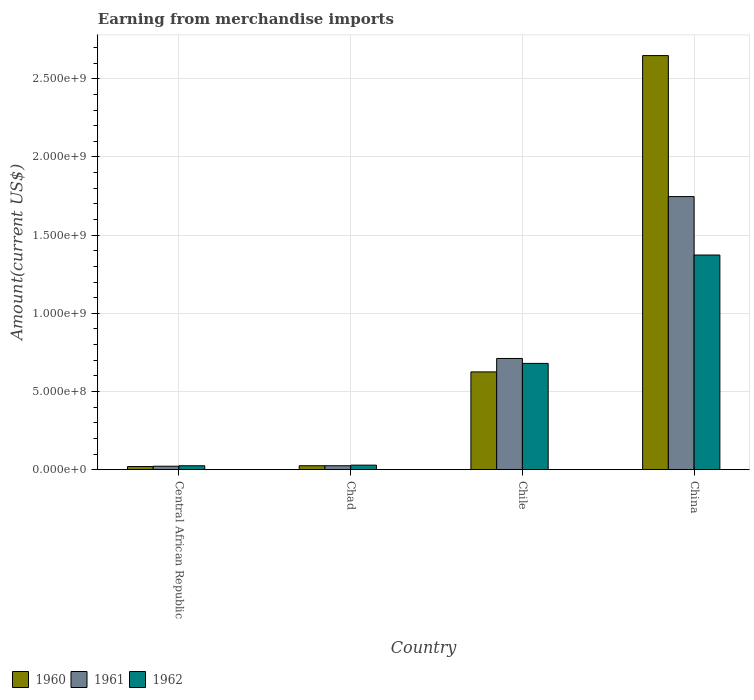How many bars are there on the 2nd tick from the left?
Make the answer very short. 3. How many bars are there on the 4th tick from the right?
Ensure brevity in your answer.  3. What is the label of the 2nd group of bars from the left?
Give a very brief answer. Chad. In how many cases, is the number of bars for a given country not equal to the number of legend labels?
Keep it short and to the point. 0. What is the amount earned from merchandise imports in 1960 in Chile?
Your response must be concise. 6.25e+08. Across all countries, what is the maximum amount earned from merchandise imports in 1961?
Make the answer very short. 1.75e+09. Across all countries, what is the minimum amount earned from merchandise imports in 1962?
Keep it short and to the point. 2.52e+07. In which country was the amount earned from merchandise imports in 1961 minimum?
Your answer should be very brief. Central African Republic. What is the total amount earned from merchandise imports in 1961 in the graph?
Ensure brevity in your answer.  2.51e+09. What is the difference between the amount earned from merchandise imports in 1962 in Chad and that in Chile?
Keep it short and to the point. -6.51e+08. What is the difference between the amount earned from merchandise imports in 1962 in Chad and the amount earned from merchandise imports in 1961 in Chile?
Ensure brevity in your answer.  -6.82e+08. What is the average amount earned from merchandise imports in 1961 per country?
Ensure brevity in your answer.  6.26e+08. What is the difference between the amount earned from merchandise imports of/in 1960 and amount earned from merchandise imports of/in 1961 in Chile?
Offer a very short reply. -8.59e+07. What is the ratio of the amount earned from merchandise imports in 1961 in Chad to that in China?
Offer a terse response. 0.01. Is the difference between the amount earned from merchandise imports in 1960 in Chad and Chile greater than the difference between the amount earned from merchandise imports in 1961 in Chad and Chile?
Your response must be concise. Yes. What is the difference between the highest and the second highest amount earned from merchandise imports in 1961?
Your answer should be very brief. 1.72e+09. What is the difference between the highest and the lowest amount earned from merchandise imports in 1960?
Your answer should be very brief. 2.63e+09. What does the 3rd bar from the right in China represents?
Offer a very short reply. 1960. Is it the case that in every country, the sum of the amount earned from merchandise imports in 1962 and amount earned from merchandise imports in 1960 is greater than the amount earned from merchandise imports in 1961?
Offer a terse response. Yes. Are all the bars in the graph horizontal?
Keep it short and to the point. No. What is the difference between two consecutive major ticks on the Y-axis?
Offer a terse response. 5.00e+08. Are the values on the major ticks of Y-axis written in scientific E-notation?
Offer a terse response. Yes. Does the graph contain grids?
Offer a very short reply. Yes. How are the legend labels stacked?
Make the answer very short. Horizontal. What is the title of the graph?
Your answer should be very brief. Earning from merchandise imports. What is the label or title of the X-axis?
Your response must be concise. Country. What is the label or title of the Y-axis?
Your answer should be very brief. Amount(current US$). What is the Amount(current US$) of 1960 in Central African Republic?
Your answer should be very brief. 2.01e+07. What is the Amount(current US$) in 1961 in Central African Republic?
Make the answer very short. 2.23e+07. What is the Amount(current US$) of 1962 in Central African Republic?
Offer a very short reply. 2.52e+07. What is the Amount(current US$) in 1960 in Chad?
Your answer should be very brief. 2.53e+07. What is the Amount(current US$) of 1961 in Chad?
Your answer should be very brief. 2.53e+07. What is the Amount(current US$) of 1962 in Chad?
Provide a succinct answer. 2.91e+07. What is the Amount(current US$) in 1960 in Chile?
Provide a short and direct response. 6.25e+08. What is the Amount(current US$) in 1961 in Chile?
Keep it short and to the point. 7.11e+08. What is the Amount(current US$) in 1962 in Chile?
Make the answer very short. 6.80e+08. What is the Amount(current US$) in 1960 in China?
Offer a terse response. 2.65e+09. What is the Amount(current US$) in 1961 in China?
Your answer should be very brief. 1.75e+09. What is the Amount(current US$) of 1962 in China?
Your answer should be very brief. 1.37e+09. Across all countries, what is the maximum Amount(current US$) of 1960?
Ensure brevity in your answer.  2.65e+09. Across all countries, what is the maximum Amount(current US$) of 1961?
Provide a succinct answer. 1.75e+09. Across all countries, what is the maximum Amount(current US$) in 1962?
Keep it short and to the point. 1.37e+09. Across all countries, what is the minimum Amount(current US$) of 1960?
Your response must be concise. 2.01e+07. Across all countries, what is the minimum Amount(current US$) of 1961?
Keep it short and to the point. 2.23e+07. Across all countries, what is the minimum Amount(current US$) of 1962?
Your response must be concise. 2.52e+07. What is the total Amount(current US$) in 1960 in the graph?
Provide a short and direct response. 3.32e+09. What is the total Amount(current US$) of 1961 in the graph?
Provide a short and direct response. 2.51e+09. What is the total Amount(current US$) of 1962 in the graph?
Offer a very short reply. 2.11e+09. What is the difference between the Amount(current US$) in 1960 in Central African Republic and that in Chad?
Make the answer very short. -5.18e+06. What is the difference between the Amount(current US$) in 1961 in Central African Republic and that in Chad?
Your response must be concise. -3.05e+06. What is the difference between the Amount(current US$) of 1962 in Central African Republic and that in Chad?
Give a very brief answer. -3.95e+06. What is the difference between the Amount(current US$) of 1960 in Central African Republic and that in Chile?
Your response must be concise. -6.05e+08. What is the difference between the Amount(current US$) in 1961 in Central African Republic and that in Chile?
Offer a very short reply. -6.89e+08. What is the difference between the Amount(current US$) in 1962 in Central African Republic and that in Chile?
Provide a short and direct response. -6.55e+08. What is the difference between the Amount(current US$) of 1960 in Central African Republic and that in China?
Your response must be concise. -2.63e+09. What is the difference between the Amount(current US$) in 1961 in Central African Republic and that in China?
Give a very brief answer. -1.72e+09. What is the difference between the Amount(current US$) in 1962 in Central African Republic and that in China?
Provide a short and direct response. -1.35e+09. What is the difference between the Amount(current US$) of 1960 in Chad and that in Chile?
Your answer should be compact. -6.00e+08. What is the difference between the Amount(current US$) of 1961 in Chad and that in Chile?
Give a very brief answer. -6.86e+08. What is the difference between the Amount(current US$) of 1962 in Chad and that in Chile?
Provide a short and direct response. -6.51e+08. What is the difference between the Amount(current US$) in 1960 in Chad and that in China?
Offer a very short reply. -2.62e+09. What is the difference between the Amount(current US$) in 1961 in Chad and that in China?
Provide a succinct answer. -1.72e+09. What is the difference between the Amount(current US$) of 1962 in Chad and that in China?
Ensure brevity in your answer.  -1.34e+09. What is the difference between the Amount(current US$) of 1960 in Chile and that in China?
Your answer should be compact. -2.02e+09. What is the difference between the Amount(current US$) in 1961 in Chile and that in China?
Make the answer very short. -1.04e+09. What is the difference between the Amount(current US$) in 1962 in Chile and that in China?
Keep it short and to the point. -6.93e+08. What is the difference between the Amount(current US$) in 1960 in Central African Republic and the Amount(current US$) in 1961 in Chad?
Your answer should be compact. -5.25e+06. What is the difference between the Amount(current US$) in 1960 in Central African Republic and the Amount(current US$) in 1962 in Chad?
Provide a short and direct response. -9.03e+06. What is the difference between the Amount(current US$) in 1961 in Central African Republic and the Amount(current US$) in 1962 in Chad?
Offer a terse response. -6.83e+06. What is the difference between the Amount(current US$) of 1960 in Central African Republic and the Amount(current US$) of 1961 in Chile?
Ensure brevity in your answer.  -6.91e+08. What is the difference between the Amount(current US$) in 1960 in Central African Republic and the Amount(current US$) in 1962 in Chile?
Offer a very short reply. -6.60e+08. What is the difference between the Amount(current US$) in 1961 in Central African Republic and the Amount(current US$) in 1962 in Chile?
Ensure brevity in your answer.  -6.58e+08. What is the difference between the Amount(current US$) of 1960 in Central African Republic and the Amount(current US$) of 1961 in China?
Provide a short and direct response. -1.73e+09. What is the difference between the Amount(current US$) of 1960 in Central African Republic and the Amount(current US$) of 1962 in China?
Offer a terse response. -1.35e+09. What is the difference between the Amount(current US$) of 1961 in Central African Republic and the Amount(current US$) of 1962 in China?
Your answer should be very brief. -1.35e+09. What is the difference between the Amount(current US$) in 1960 in Chad and the Amount(current US$) in 1961 in Chile?
Make the answer very short. -6.86e+08. What is the difference between the Amount(current US$) of 1960 in Chad and the Amount(current US$) of 1962 in Chile?
Give a very brief answer. -6.55e+08. What is the difference between the Amount(current US$) of 1961 in Chad and the Amount(current US$) of 1962 in Chile?
Ensure brevity in your answer.  -6.55e+08. What is the difference between the Amount(current US$) in 1960 in Chad and the Amount(current US$) in 1961 in China?
Provide a short and direct response. -1.72e+09. What is the difference between the Amount(current US$) in 1960 in Chad and the Amount(current US$) in 1962 in China?
Provide a short and direct response. -1.35e+09. What is the difference between the Amount(current US$) of 1961 in Chad and the Amount(current US$) of 1962 in China?
Keep it short and to the point. -1.35e+09. What is the difference between the Amount(current US$) in 1960 in Chile and the Amount(current US$) in 1961 in China?
Offer a very short reply. -1.12e+09. What is the difference between the Amount(current US$) in 1960 in Chile and the Amount(current US$) in 1962 in China?
Your response must be concise. -7.48e+08. What is the difference between the Amount(current US$) of 1961 in Chile and the Amount(current US$) of 1962 in China?
Ensure brevity in your answer.  -6.62e+08. What is the average Amount(current US$) in 1960 per country?
Keep it short and to the point. 8.30e+08. What is the average Amount(current US$) of 1961 per country?
Your answer should be compact. 6.26e+08. What is the average Amount(current US$) in 1962 per country?
Provide a short and direct response. 5.27e+08. What is the difference between the Amount(current US$) in 1960 and Amount(current US$) in 1961 in Central African Republic?
Offer a very short reply. -2.20e+06. What is the difference between the Amount(current US$) in 1960 and Amount(current US$) in 1962 in Central African Republic?
Give a very brief answer. -5.08e+06. What is the difference between the Amount(current US$) of 1961 and Amount(current US$) of 1962 in Central African Republic?
Provide a short and direct response. -2.88e+06. What is the difference between the Amount(current US$) of 1960 and Amount(current US$) of 1961 in Chad?
Provide a succinct answer. -7.30e+04. What is the difference between the Amount(current US$) of 1960 and Amount(current US$) of 1962 in Chad?
Your answer should be compact. -3.84e+06. What is the difference between the Amount(current US$) of 1961 and Amount(current US$) of 1962 in Chad?
Provide a succinct answer. -3.77e+06. What is the difference between the Amount(current US$) of 1960 and Amount(current US$) of 1961 in Chile?
Make the answer very short. -8.59e+07. What is the difference between the Amount(current US$) of 1960 and Amount(current US$) of 1962 in Chile?
Your response must be concise. -5.44e+07. What is the difference between the Amount(current US$) of 1961 and Amount(current US$) of 1962 in Chile?
Make the answer very short. 3.15e+07. What is the difference between the Amount(current US$) of 1960 and Amount(current US$) of 1961 in China?
Your response must be concise. 9.02e+08. What is the difference between the Amount(current US$) in 1960 and Amount(current US$) in 1962 in China?
Provide a short and direct response. 1.28e+09. What is the difference between the Amount(current US$) in 1961 and Amount(current US$) in 1962 in China?
Provide a short and direct response. 3.74e+08. What is the ratio of the Amount(current US$) in 1960 in Central African Republic to that in Chad?
Make the answer very short. 0.79. What is the ratio of the Amount(current US$) in 1961 in Central African Republic to that in Chad?
Your response must be concise. 0.88. What is the ratio of the Amount(current US$) of 1962 in Central African Republic to that in Chad?
Keep it short and to the point. 0.86. What is the ratio of the Amount(current US$) in 1960 in Central African Republic to that in Chile?
Your answer should be very brief. 0.03. What is the ratio of the Amount(current US$) in 1961 in Central African Republic to that in Chile?
Offer a terse response. 0.03. What is the ratio of the Amount(current US$) in 1962 in Central African Republic to that in Chile?
Your answer should be compact. 0.04. What is the ratio of the Amount(current US$) in 1960 in Central African Republic to that in China?
Ensure brevity in your answer.  0.01. What is the ratio of the Amount(current US$) of 1961 in Central African Republic to that in China?
Keep it short and to the point. 0.01. What is the ratio of the Amount(current US$) in 1962 in Central African Republic to that in China?
Your answer should be compact. 0.02. What is the ratio of the Amount(current US$) of 1960 in Chad to that in Chile?
Keep it short and to the point. 0.04. What is the ratio of the Amount(current US$) in 1961 in Chad to that in Chile?
Ensure brevity in your answer.  0.04. What is the ratio of the Amount(current US$) in 1962 in Chad to that in Chile?
Provide a short and direct response. 0.04. What is the ratio of the Amount(current US$) in 1960 in Chad to that in China?
Make the answer very short. 0.01. What is the ratio of the Amount(current US$) of 1961 in Chad to that in China?
Give a very brief answer. 0.01. What is the ratio of the Amount(current US$) of 1962 in Chad to that in China?
Make the answer very short. 0.02. What is the ratio of the Amount(current US$) of 1960 in Chile to that in China?
Offer a terse response. 0.24. What is the ratio of the Amount(current US$) in 1961 in Chile to that in China?
Offer a very short reply. 0.41. What is the ratio of the Amount(current US$) in 1962 in Chile to that in China?
Your answer should be compact. 0.5. What is the difference between the highest and the second highest Amount(current US$) in 1960?
Provide a short and direct response. 2.02e+09. What is the difference between the highest and the second highest Amount(current US$) in 1961?
Ensure brevity in your answer.  1.04e+09. What is the difference between the highest and the second highest Amount(current US$) of 1962?
Your answer should be very brief. 6.93e+08. What is the difference between the highest and the lowest Amount(current US$) of 1960?
Make the answer very short. 2.63e+09. What is the difference between the highest and the lowest Amount(current US$) of 1961?
Provide a short and direct response. 1.72e+09. What is the difference between the highest and the lowest Amount(current US$) in 1962?
Give a very brief answer. 1.35e+09. 